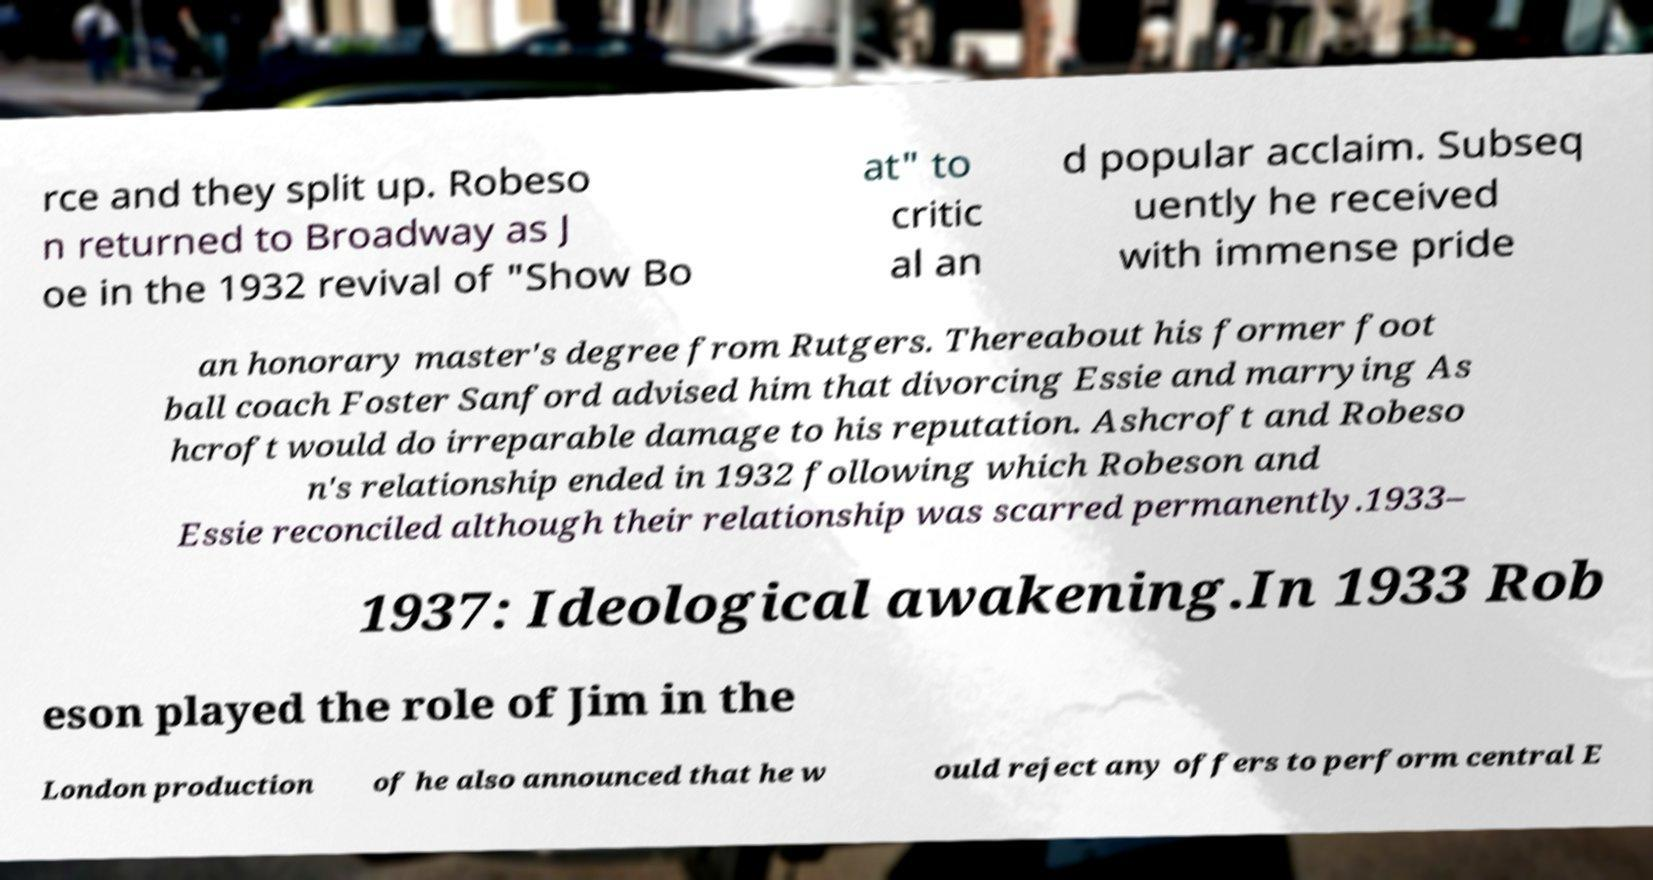There's text embedded in this image that I need extracted. Can you transcribe it verbatim? rce and they split up. Robeso n returned to Broadway as J oe in the 1932 revival of "Show Bo at" to critic al an d popular acclaim. Subseq uently he received with immense pride an honorary master's degree from Rutgers. Thereabout his former foot ball coach Foster Sanford advised him that divorcing Essie and marrying As hcroft would do irreparable damage to his reputation. Ashcroft and Robeso n's relationship ended in 1932 following which Robeson and Essie reconciled although their relationship was scarred permanently.1933– 1937: Ideological awakening.In 1933 Rob eson played the role of Jim in the London production of he also announced that he w ould reject any offers to perform central E 